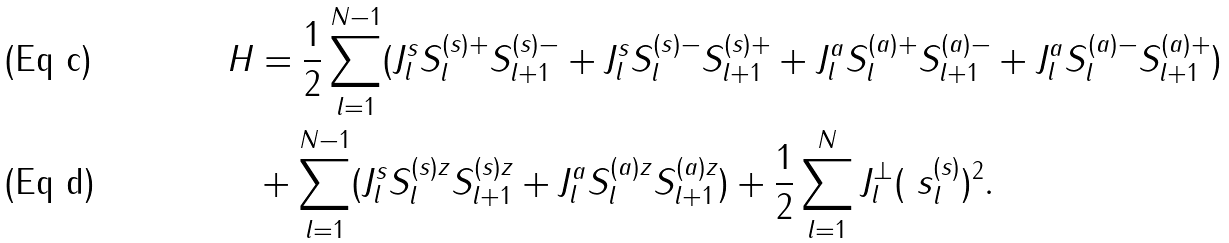Convert formula to latex. <formula><loc_0><loc_0><loc_500><loc_500>H & = \frac { 1 } { 2 } \sum _ { l = 1 } ^ { N - 1 } ( J ^ { s } _ { l } S ^ { ( s ) + } _ { l } S ^ { ( s ) - } _ { l + 1 } + J ^ { s } _ { l } S ^ { ( s ) - } _ { l } S ^ { ( s ) + } _ { l + 1 } + J ^ { a } _ { l } S ^ { ( a ) + } _ { l } S ^ { ( a ) - } _ { l + 1 } + J ^ { a } _ { l } S ^ { ( a ) - } _ { l } S ^ { ( a ) + } _ { l + 1 } ) \\ & + \sum _ { l = 1 } ^ { N - 1 } ( J ^ { s } _ { l } S ^ { ( s ) z } _ { l } S ^ { ( s ) z } _ { l + 1 } + J ^ { a } _ { l } S ^ { ( a ) z } _ { l } S ^ { ( a ) z } _ { l + 1 } ) + \frac { 1 } { 2 } \sum _ { l = 1 } ^ { N } J ^ { \perp } _ { l } ( \ s ^ { ( s ) } _ { l } ) ^ { 2 } .</formula> 